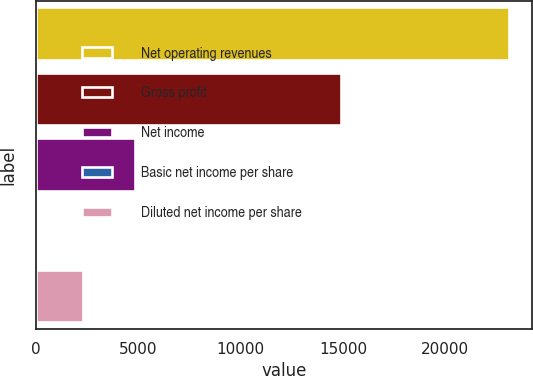<chart> <loc_0><loc_0><loc_500><loc_500><bar_chart><fcel>Net operating revenues<fcel>Gross profit<fcel>Net income<fcel>Basic net income per share<fcel>Diluted net income per share<nl><fcel>23104<fcel>14909<fcel>4872<fcel>2.04<fcel>2312.24<nl></chart> 